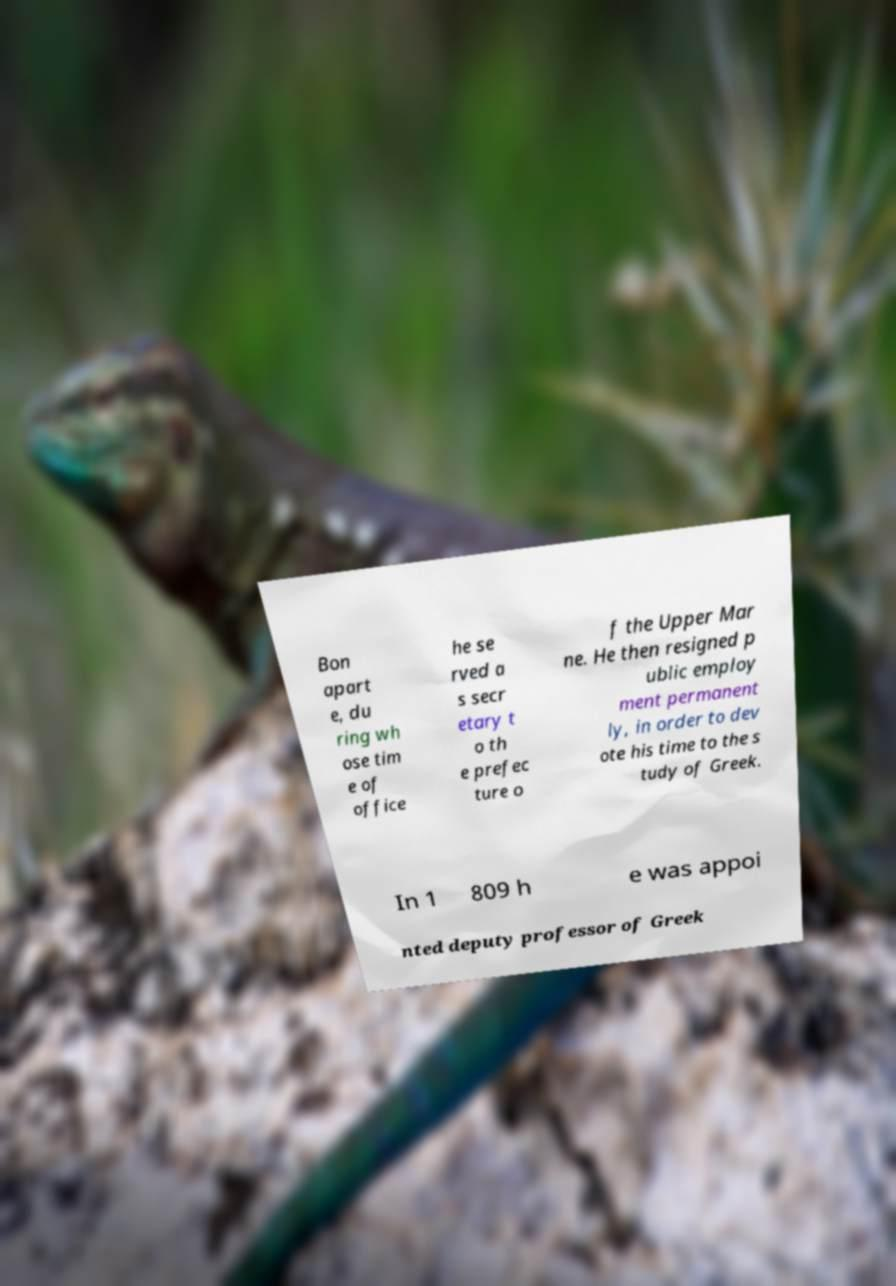Please read and relay the text visible in this image. What does it say? Bon apart e, du ring wh ose tim e of office he se rved a s secr etary t o th e prefec ture o f the Upper Mar ne. He then resigned p ublic employ ment permanent ly, in order to dev ote his time to the s tudy of Greek. In 1 809 h e was appoi nted deputy professor of Greek 